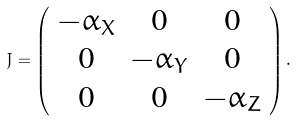Convert formula to latex. <formula><loc_0><loc_0><loc_500><loc_500>J = \left ( \begin{array} { c c c } - \alpha _ { X } & 0 & 0 \\ 0 & - \alpha _ { Y } & 0 \\ 0 & 0 & - \alpha _ { Z } \\ \end{array} \right ) .</formula> 